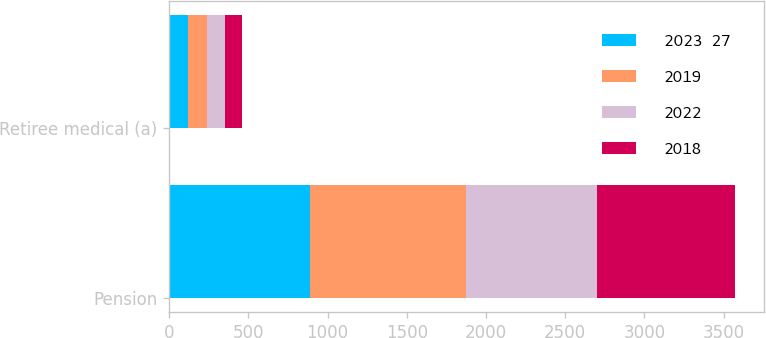Convert chart. <chart><loc_0><loc_0><loc_500><loc_500><stacked_bar_chart><ecel><fcel>Pension<fcel>Retiree medical (a)<nl><fcel>2023  27<fcel>890<fcel>120<nl><fcel>2019<fcel>985<fcel>120<nl><fcel>2022<fcel>825<fcel>110<nl><fcel>2018<fcel>875<fcel>110<nl></chart> 